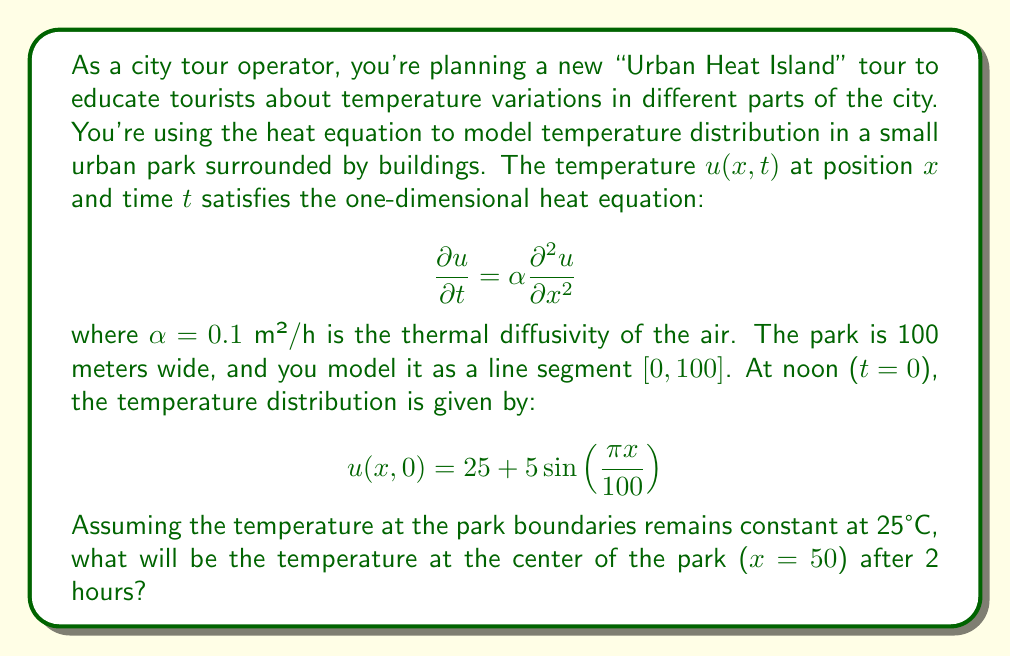Help me with this question. To solve this problem, we need to use the solution to the heat equation with given initial and boundary conditions. The general solution for the one-dimensional heat equation with constant boundary conditions is:

$$u(x,t) = A_0 + \sum_{n=1}^{\infty} A_n \sin\left(\frac{n\pi x}{L}\right) e^{-\alpha n^2 \pi^2 t / L^2}$$

where $L$ is the length of the domain (in this case, 100 meters).

Given the initial condition:

$$u(x,0) = 25 + 5\sin\left(\frac{\pi x}{100}\right)$$

We can see that $A_0 = 25$ and $A_1 = 5$, with all other $A_n = 0$ for $n > 1$.

Therefore, our solution simplifies to:

$$u(x,t) = 25 + 5\sin\left(\frac{\pi x}{100}\right) e^{-0.1 \pi^2 t / 10000}$$

To find the temperature at the center of the park ($x=50$) after 2 hours ($t=2$), we substitute these values:

$$\begin{align*}
u(50,2) &= 25 + 5\sin\left(\frac{\pi \cdot 50}{100}\right) e^{-0.1 \pi^2 \cdot 2 / 10000} \\
&= 25 + 5\sin\left(\frac{\pi}{2}\right) e^{-\pi^2 / 50000} \\
&= 25 + 5 \cdot 1 \cdot e^{-\pi^2 / 50000} \\
&\approx 25 + 5 \cdot 0.9998 \\
&\approx 29.999 \text{ °C}
\end{align*}$$
Answer: The temperature at the center of the park after 2 hours will be approximately 29.999°C. 